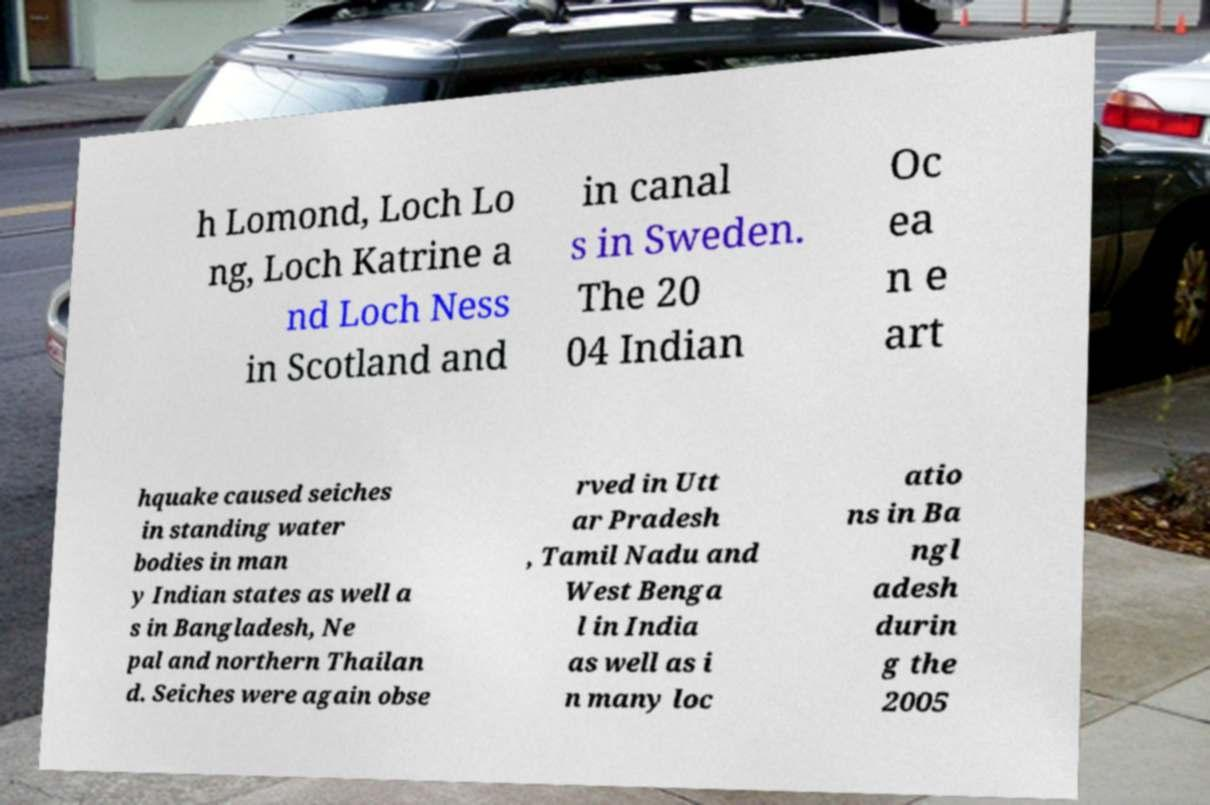Can you read and provide the text displayed in the image?This photo seems to have some interesting text. Can you extract and type it out for me? h Lomond, Loch Lo ng, Loch Katrine a nd Loch Ness in Scotland and in canal s in Sweden. The 20 04 Indian Oc ea n e art hquake caused seiches in standing water bodies in man y Indian states as well a s in Bangladesh, Ne pal and northern Thailan d. Seiches were again obse rved in Utt ar Pradesh , Tamil Nadu and West Benga l in India as well as i n many loc atio ns in Ba ngl adesh durin g the 2005 